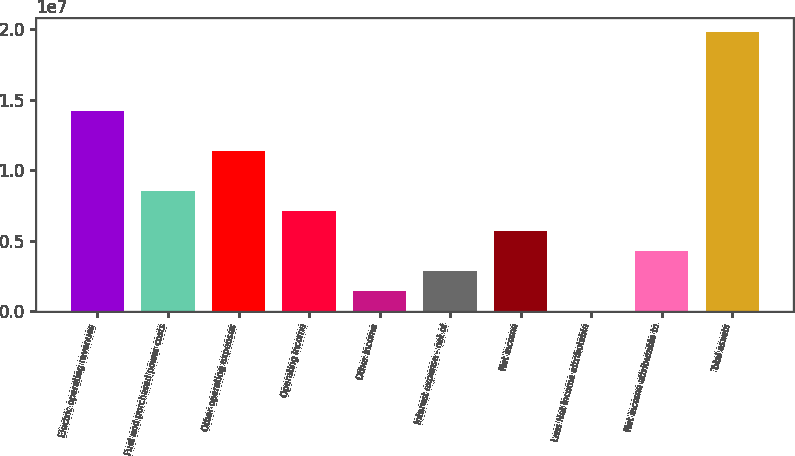<chart> <loc_0><loc_0><loc_500><loc_500><bar_chart><fcel>Electric operating revenues<fcel>Fuel and purchased power costs<fcel>Other operating expenses<fcel>Operating income<fcel>Other income<fcel>Interest expense - net of<fcel>Net income<fcel>Less Net income attributable<fcel>Net income attributable to<fcel>Total assets<nl><fcel>1.41904e+07<fcel>8.52466e+06<fcel>1.13575e+07<fcel>7.10823e+06<fcel>1.44253e+06<fcel>2.85895e+06<fcel>5.69181e+06<fcel>26101<fcel>4.27538e+06<fcel>1.98561e+07<nl></chart> 